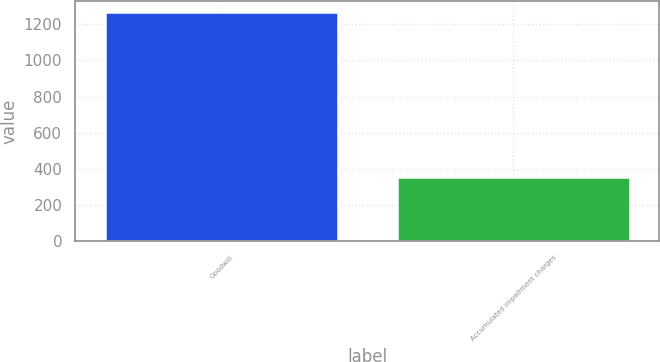Convert chart to OTSL. <chart><loc_0><loc_0><loc_500><loc_500><bar_chart><fcel>Goodwill<fcel>Accumulated impairment charges<nl><fcel>1265.4<fcel>354.1<nl></chart> 